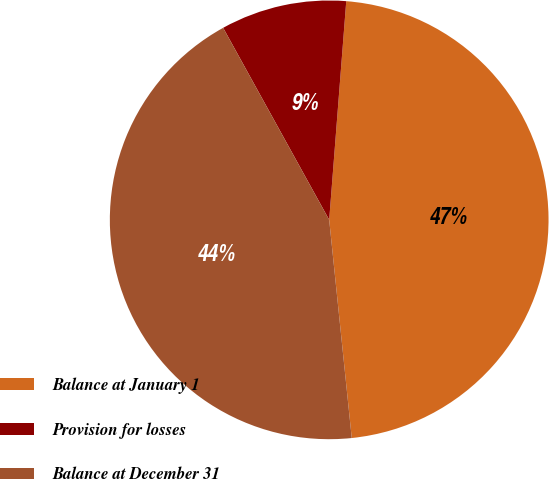Convert chart to OTSL. <chart><loc_0><loc_0><loc_500><loc_500><pie_chart><fcel>Balance at January 1<fcel>Provision for losses<fcel>Balance at December 31<nl><fcel>47.12%<fcel>9.27%<fcel>43.61%<nl></chart> 